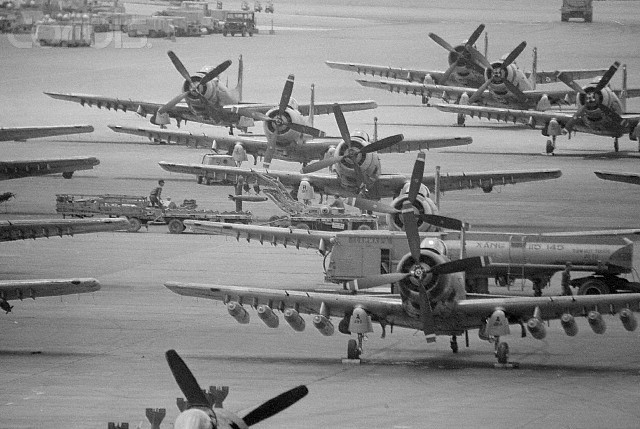Describe the objects in this image and their specific colors. I can see airplane in darkgray, gray, black, and lightgray tones, airplane in darkgray, gray, black, and lightgray tones, airplane in darkgray, gray, black, and lightgray tones, airplane in darkgray, gray, lightgray, and black tones, and airplane in darkgray, gray, lightgray, and black tones in this image. 